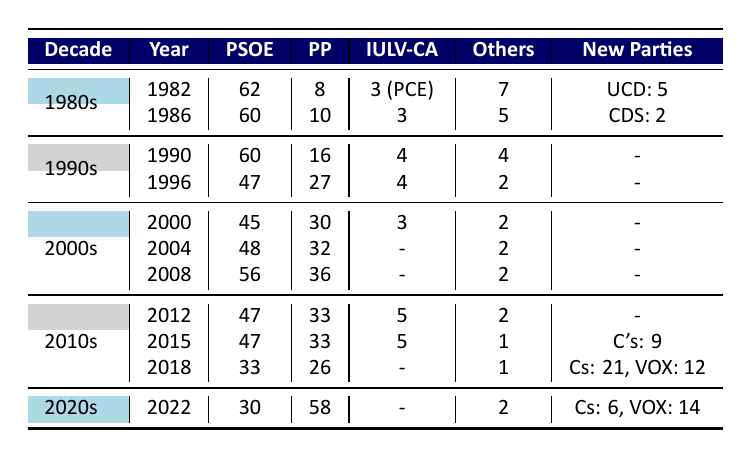What was the total number of PSOE representatives in the 1982 elections? The table shows that in 1982, PSOE had 62 representatives. Therefore, the total number of representatives is directly taken from this entry in the table.
Answer: 62 How many representatives did the PP have in the year 1996? Referring to the 1996 election data in the table, it confirms that PP had 27 representatives.
Answer: 27 What was the change in the number of PSOE representatives from 1982 to 1986? In 1982, PSOE had 62 representatives, and in 1986, they had 60. Calculating the change involves the difference: 62 - 60 = 2. Therefore, PSOE lost 2 representatives from 1982 to 1986.
Answer: 2 Which party had the highest number of representatives in the 2008 elections? By checking the 2008 election data, SOE had 56, and PP had 36. Since 56 (PSOE) is greater than 36 (PP), we conclude that PSOE had the highest number of representatives in this election.
Answer: PSOE How many total representatives did the new parties have in the 2018 elections? In the 2018 elections, the new parties listed are Cs with 21 representatives and VOX with 12. We add these two numbers: 21 + 12 = 33, so new parties had a total of 33 representatives.
Answer: 33 Did the number of representatives from IULV-CA decrease from the 2000 elections to the 2012 elections? In the 2000 elections, IULV-CA had 3 representatives, and in 2012, it had 5 representatives. Since 5 is greater than 3, the number of representatives for IULV-CA did not decrease but instead increased.
Answer: No What was the lowest number of representatives that PSOE had from 1980 to 2022? By comparing all the election data, it is evident that PSOE had its lowest representation of 30 in the 2022 elections. Thus, the lowest number of representatives for PSOE is 30.
Answer: 30 How did the number of "Others" representatives change from the 1980s to the 2020s? In the 1980s, in total, "Others" had 7 representatives in 1982 and 5 in 1986 (noting the average: (7 + 5) / 2 = 6). In the 2020 elections, "Others" had 2. Therefore, the change can be summarized as a decline from an average of 6 to 2.
Answer: Decreased What was the percentage representation increase of PP from the 2015 elections to the 2022 elections? In 2015, PP had 33 representatives, which increased to 58 in 2022. The increase is calculated as: (58 - 33) / 33 * 100 = 75.76%. Thus, the percentage increase of PP representation is about 75.76%.
Answer: 75.76% 